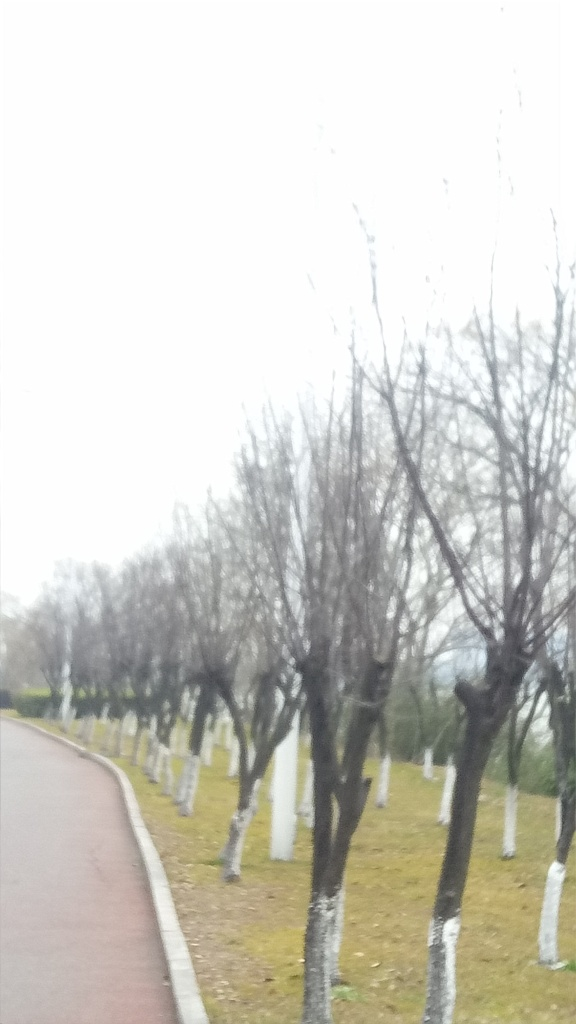Could you describe the overall atmosphere of the image? The image conveys a serene and possibly cold atmosphere, judging by the bare trees and overcast sky. The pathway suggests a quiet park setting, ideal for reflective walks. The white paint at the base of the trees might serve a practical purpose, potentially to protect the trees from pests or frost. 